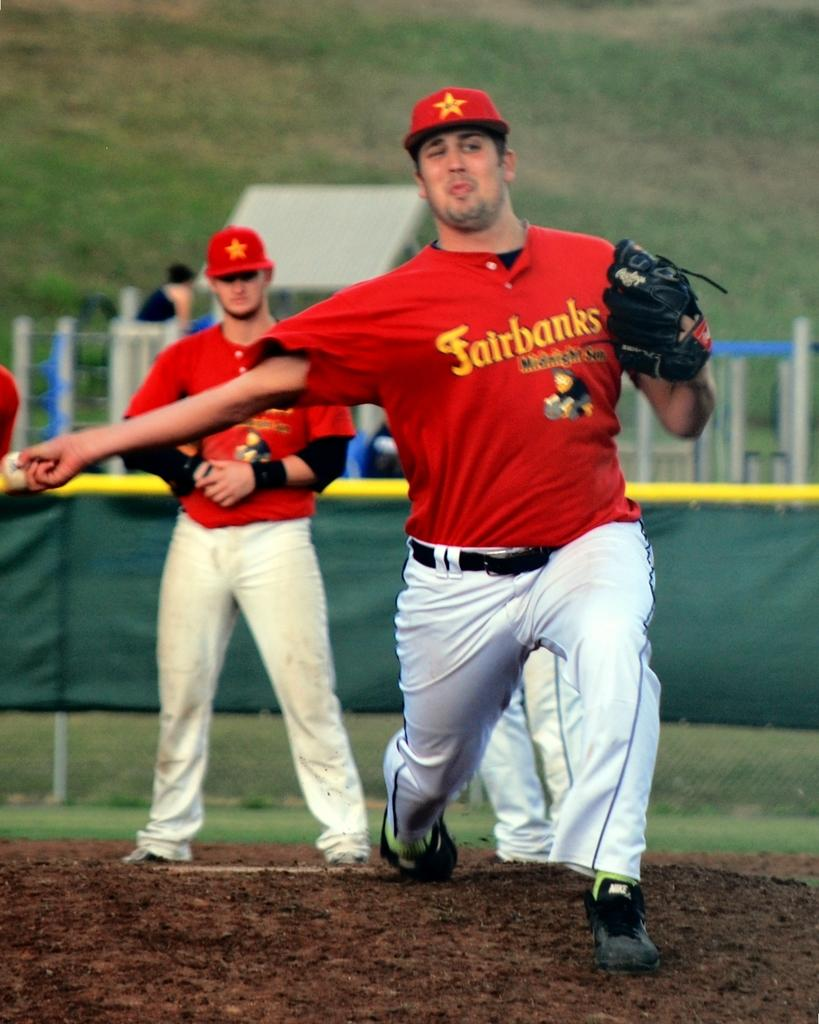<image>
Give a short and clear explanation of the subsequent image. a few players with one wearing a Fairbanks shirt 